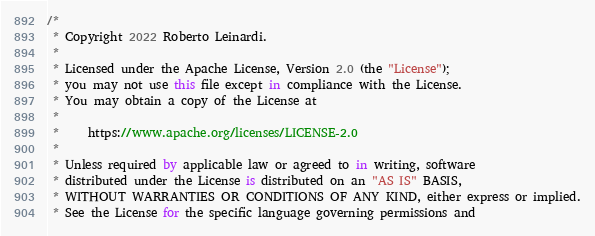Convert code to text. <code><loc_0><loc_0><loc_500><loc_500><_Kotlin_>/*
 * Copyright 2022 Roberto Leinardi.
 *
 * Licensed under the Apache License, Version 2.0 (the "License");
 * you may not use this file except in compliance with the License.
 * You may obtain a copy of the License at
 *
 *     https://www.apache.org/licenses/LICENSE-2.0
 *
 * Unless required by applicable law or agreed to in writing, software
 * distributed under the License is distributed on an "AS IS" BASIS,
 * WITHOUT WARRANTIES OR CONDITIONS OF ANY KIND, either express or implied.
 * See the License for the specific language governing permissions and</code> 